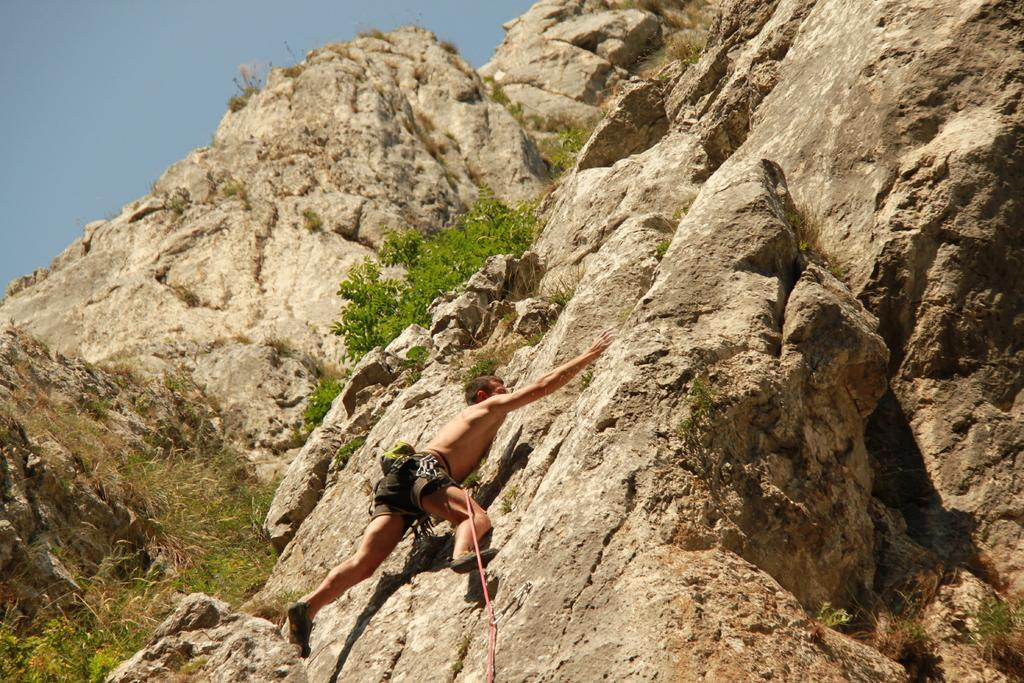Where was the image taken? The image was clicked outside. What is the person in the image doing? The person is climbing rocks in the image. What type of vegetation can be seen in the image? Green leaves and grass are visible in the image. What is the person using to climb the rocks? There is a rope in the image, which the person might be using to climb the rocks. What is visible in the background of the image? Rocks and the sky are visible in the image. What type of flag is visible in the image? There is no flag present in the image. Is the person's sister or parent visible in the image? There is no mention of a sister or parent in the image, only the person climbing rocks. 